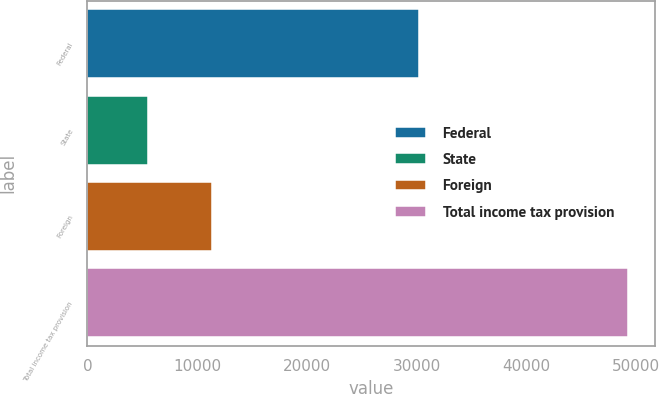<chart> <loc_0><loc_0><loc_500><loc_500><bar_chart><fcel>Federal<fcel>State<fcel>Foreign<fcel>Total income tax provision<nl><fcel>30224<fcel>5511<fcel>11389<fcel>49268<nl></chart> 